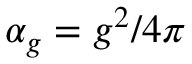<formula> <loc_0><loc_0><loc_500><loc_500>\alpha _ { g } = g ^ { 2 } / 4 \pi</formula> 